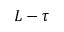<formula> <loc_0><loc_0><loc_500><loc_500>L - \tau</formula> 